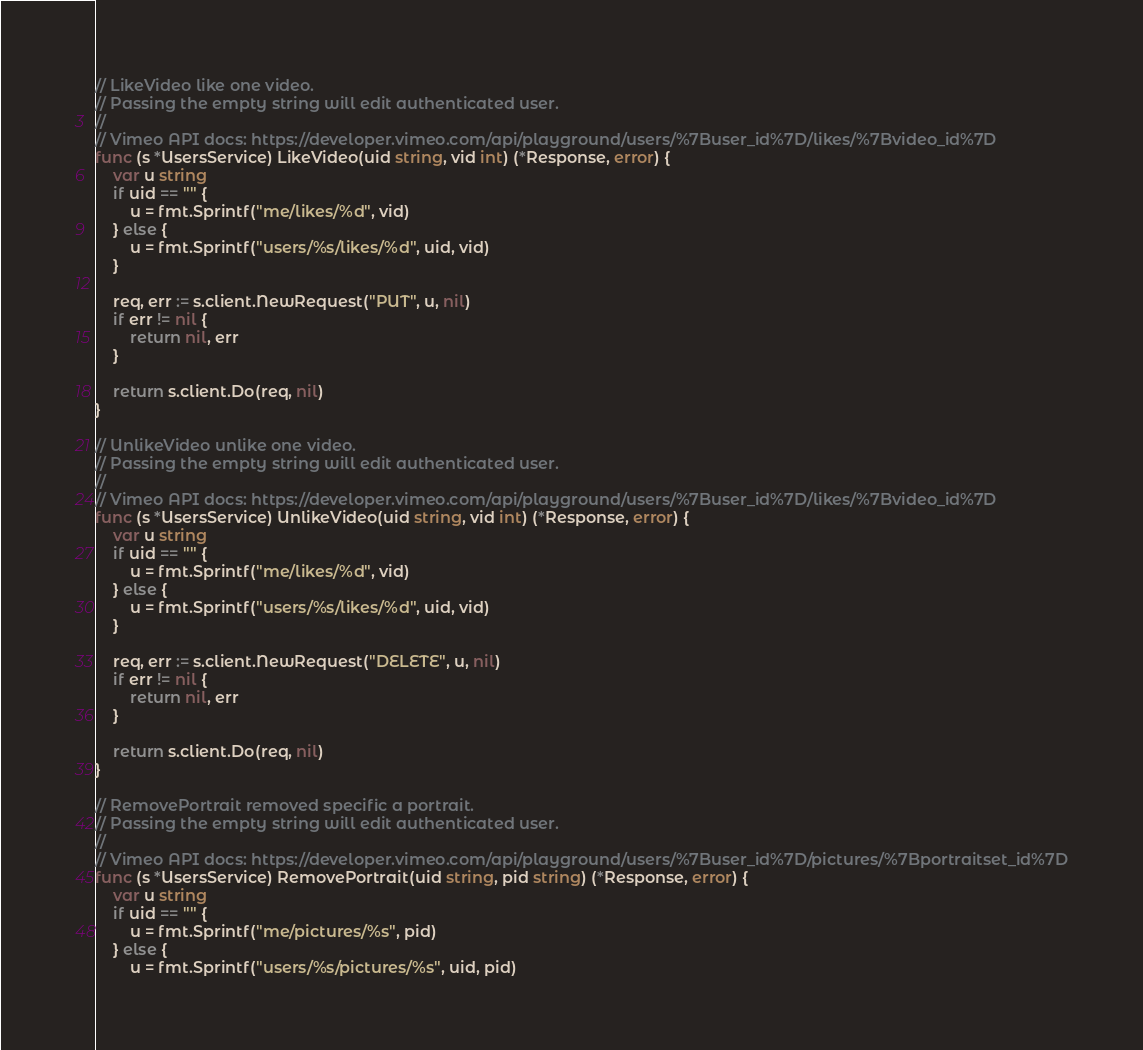<code> <loc_0><loc_0><loc_500><loc_500><_Go_>
// LikeVideo like one video.
// Passing the empty string will edit authenticated user.
//
// Vimeo API docs: https://developer.vimeo.com/api/playground/users/%7Buser_id%7D/likes/%7Bvideo_id%7D
func (s *UsersService) LikeVideo(uid string, vid int) (*Response, error) {
	var u string
	if uid == "" {
		u = fmt.Sprintf("me/likes/%d", vid)
	} else {
		u = fmt.Sprintf("users/%s/likes/%d", uid, vid)
	}

	req, err := s.client.NewRequest("PUT", u, nil)
	if err != nil {
		return nil, err
	}

	return s.client.Do(req, nil)
}

// UnlikeVideo unlike one video.
// Passing the empty string will edit authenticated user.
//
// Vimeo API docs: https://developer.vimeo.com/api/playground/users/%7Buser_id%7D/likes/%7Bvideo_id%7D
func (s *UsersService) UnlikeVideo(uid string, vid int) (*Response, error) {
	var u string
	if uid == "" {
		u = fmt.Sprintf("me/likes/%d", vid)
	} else {
		u = fmt.Sprintf("users/%s/likes/%d", uid, vid)
	}

	req, err := s.client.NewRequest("DELETE", u, nil)
	if err != nil {
		return nil, err
	}

	return s.client.Do(req, nil)
}

// RemovePortrait removed specific a portrait.
// Passing the empty string will edit authenticated user.
//
// Vimeo API docs: https://developer.vimeo.com/api/playground/users/%7Buser_id%7D/pictures/%7Bportraitset_id%7D
func (s *UsersService) RemovePortrait(uid string, pid string) (*Response, error) {
	var u string
	if uid == "" {
		u = fmt.Sprintf("me/pictures/%s", pid)
	} else {
		u = fmt.Sprintf("users/%s/pictures/%s", uid, pid)</code> 